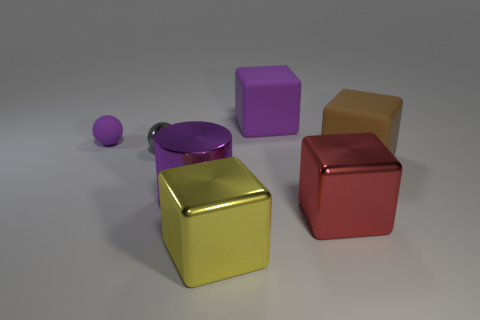Subtract all big purple matte cubes. How many cubes are left? 3 Add 1 large purple matte things. How many objects exist? 8 Subtract 1 spheres. How many spheres are left? 1 Subtract all purple spheres. How many spheres are left? 1 Subtract all cubes. How many objects are left? 3 Subtract all purple matte balls. Subtract all big blocks. How many objects are left? 2 Add 4 big brown rubber blocks. How many big brown rubber blocks are left? 5 Add 7 large gray shiny balls. How many large gray shiny balls exist? 7 Subtract 0 green cubes. How many objects are left? 7 Subtract all red blocks. Subtract all green cylinders. How many blocks are left? 3 